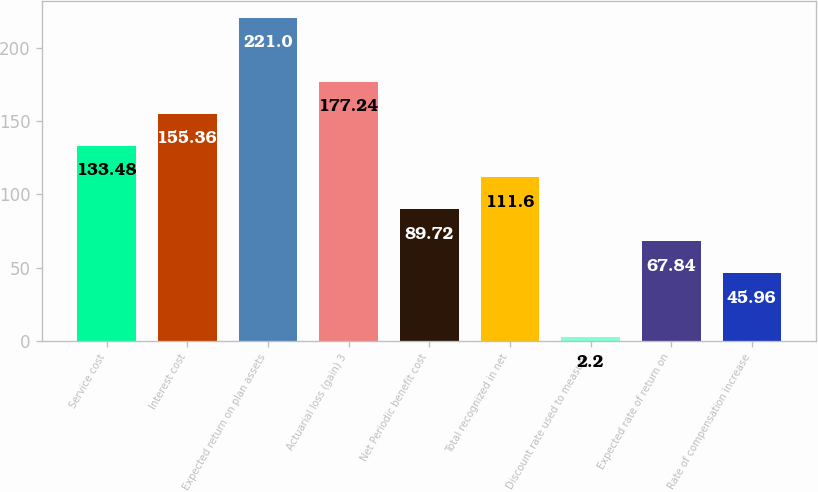Convert chart. <chart><loc_0><loc_0><loc_500><loc_500><bar_chart><fcel>Service cost<fcel>Interest cost<fcel>Expected return on plan assets<fcel>Actuarial loss (gain) 3<fcel>Net Periodic benefit cost<fcel>Total recognized in net<fcel>Discount rate used to measure<fcel>Expected rate of return on<fcel>Rate of compensation increase<nl><fcel>133.48<fcel>155.36<fcel>221<fcel>177.24<fcel>89.72<fcel>111.6<fcel>2.2<fcel>67.84<fcel>45.96<nl></chart> 